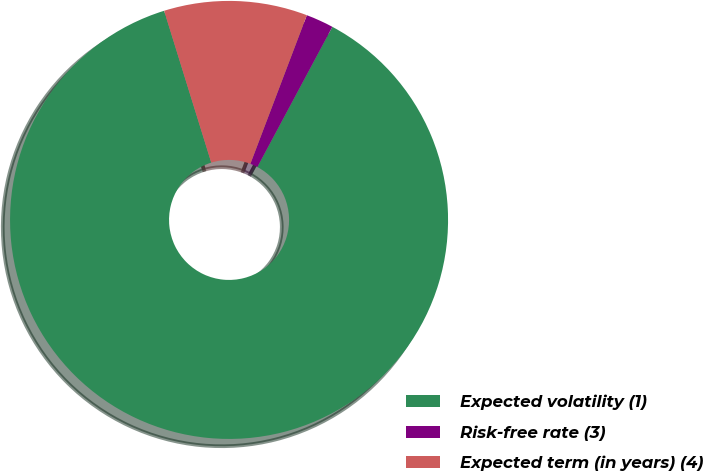<chart> <loc_0><loc_0><loc_500><loc_500><pie_chart><fcel>Expected volatility (1)<fcel>Risk-free rate (3)<fcel>Expected term (in years) (4)<nl><fcel>87.39%<fcel>2.04%<fcel>10.57%<nl></chart> 